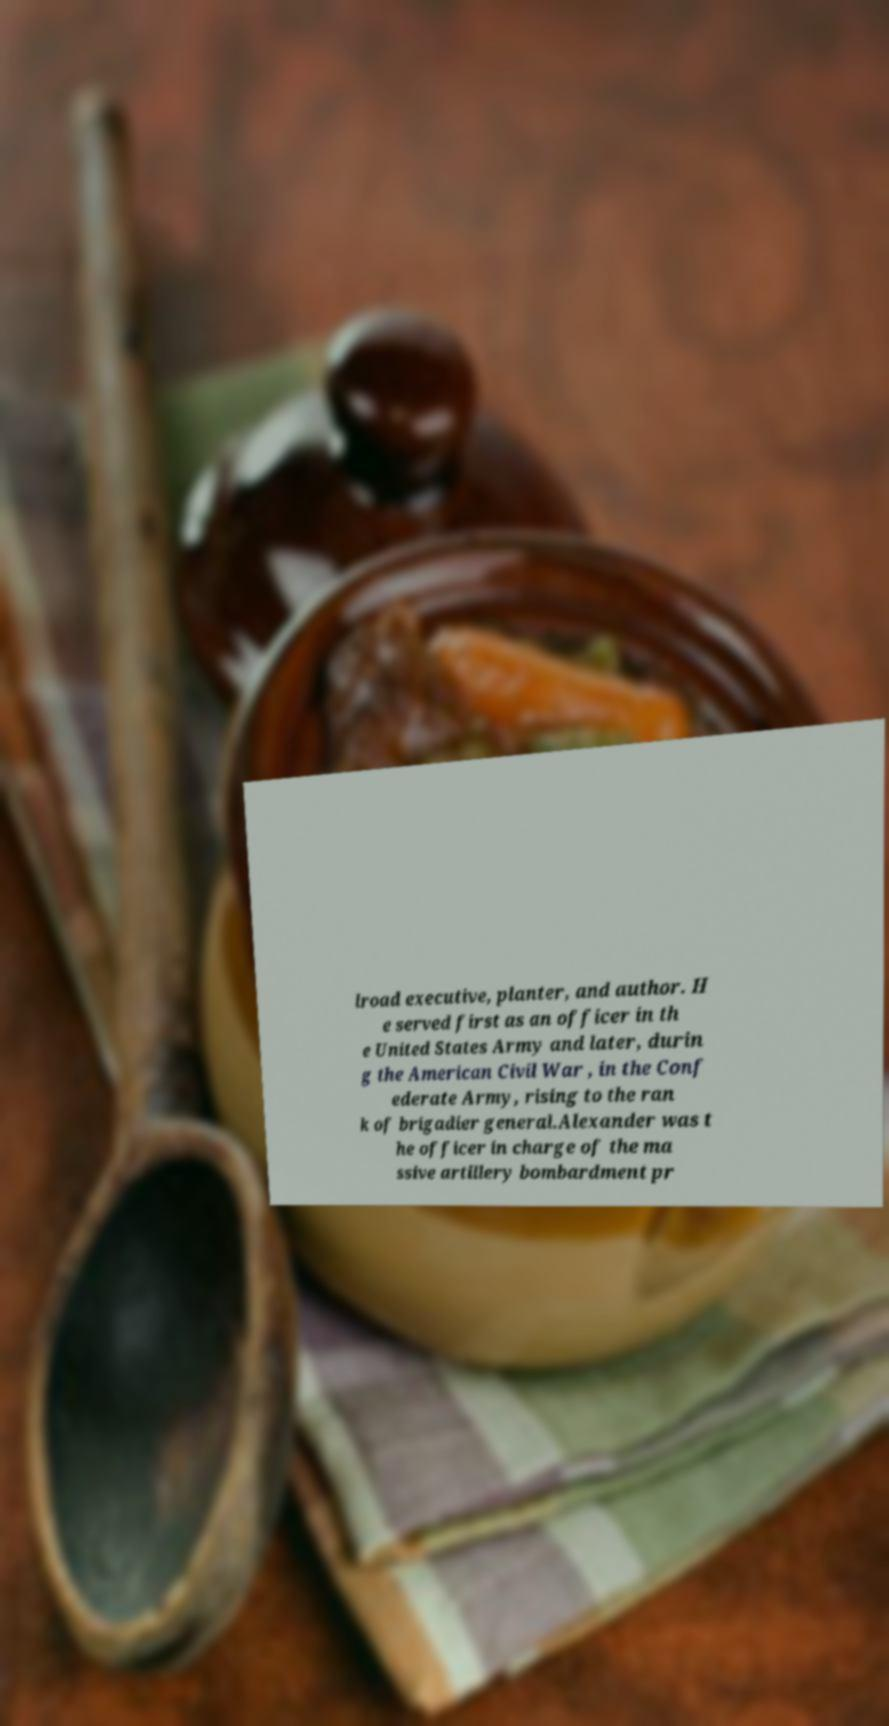There's text embedded in this image that I need extracted. Can you transcribe it verbatim? lroad executive, planter, and author. H e served first as an officer in th e United States Army and later, durin g the American Civil War , in the Conf ederate Army, rising to the ran k of brigadier general.Alexander was t he officer in charge of the ma ssive artillery bombardment pr 